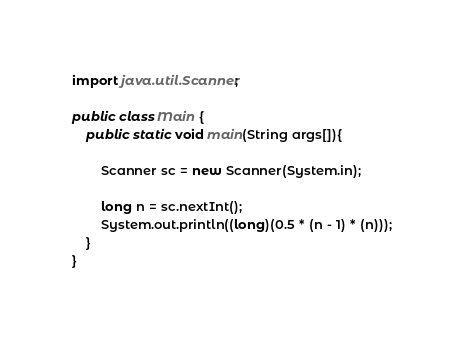<code> <loc_0><loc_0><loc_500><loc_500><_Java_>import java.util.Scanner;

public class Main {
	public static void main(String args[]){

		Scanner sc = new Scanner(System.in);

		long n = sc.nextInt();
		System.out.println((long)(0.5 * (n - 1) * (n)));
	}
}</code> 